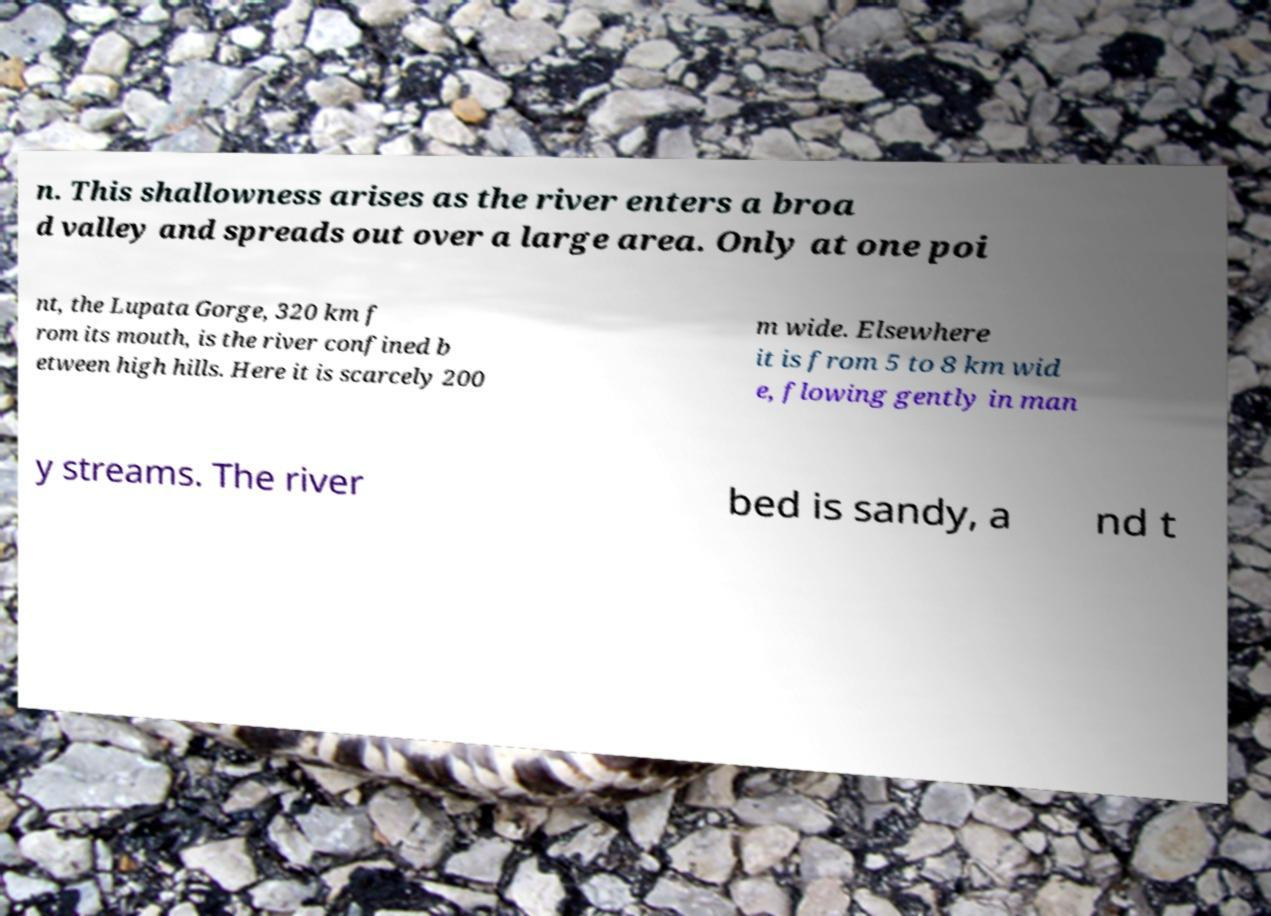Can you read and provide the text displayed in the image?This photo seems to have some interesting text. Can you extract and type it out for me? n. This shallowness arises as the river enters a broa d valley and spreads out over a large area. Only at one poi nt, the Lupata Gorge, 320 km f rom its mouth, is the river confined b etween high hills. Here it is scarcely 200 m wide. Elsewhere it is from 5 to 8 km wid e, flowing gently in man y streams. The river bed is sandy, a nd t 